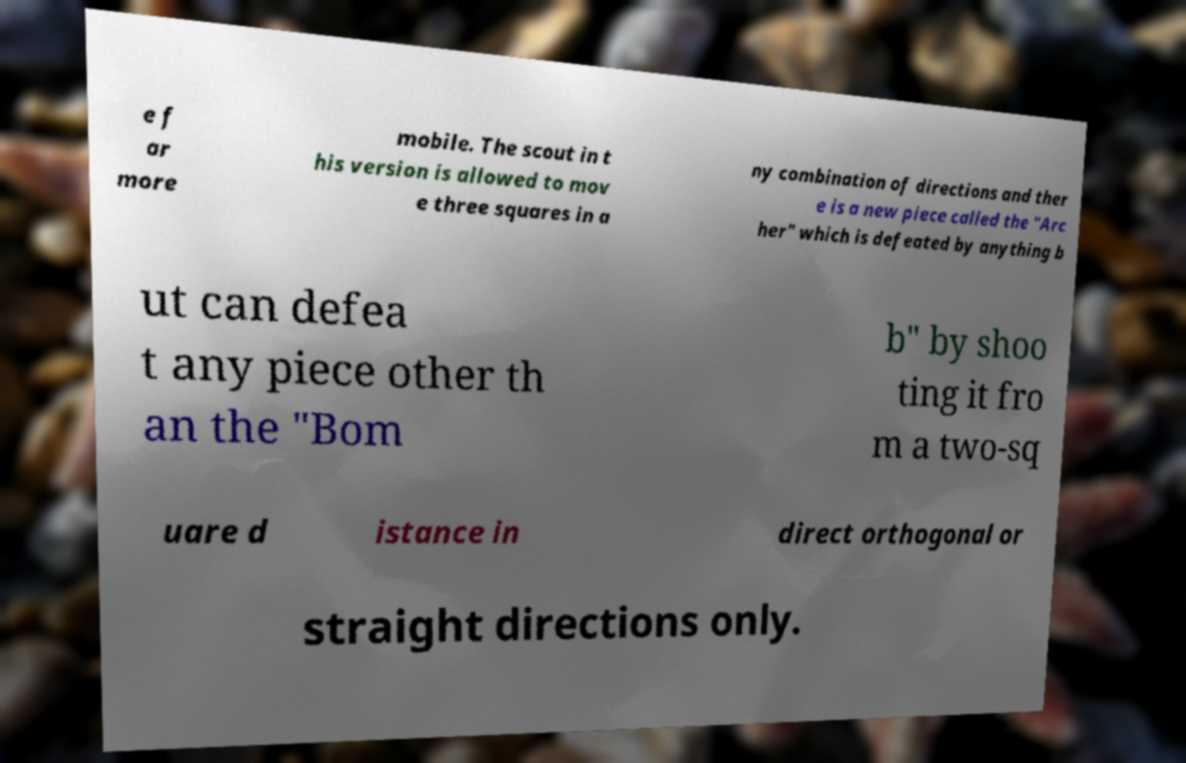Please read and relay the text visible in this image. What does it say? e f ar more mobile. The scout in t his version is allowed to mov e three squares in a ny combination of directions and ther e is a new piece called the "Arc her" which is defeated by anything b ut can defea t any piece other th an the "Bom b" by shoo ting it fro m a two-sq uare d istance in direct orthogonal or straight directions only. 